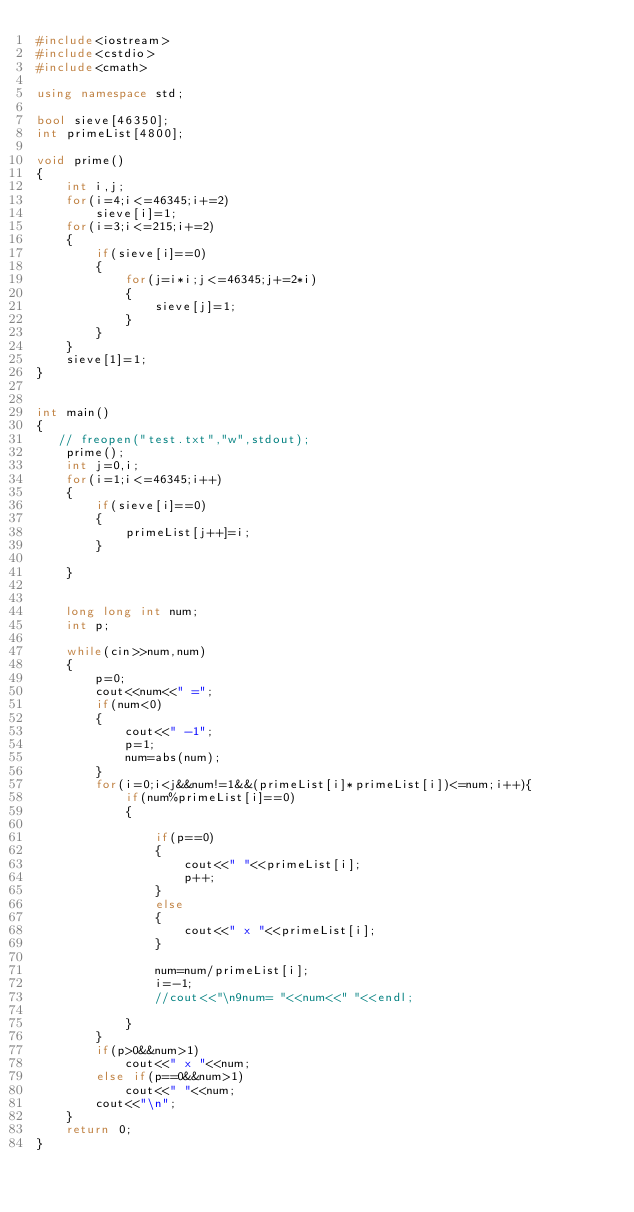Convert code to text. <code><loc_0><loc_0><loc_500><loc_500><_C++_>#include<iostream>
#include<cstdio>
#include<cmath>

using namespace std;

bool sieve[46350];
int primeList[4800];

void prime()
{
    int i,j;
    for(i=4;i<=46345;i+=2)
        sieve[i]=1;
    for(i=3;i<=215;i+=2)
    {
        if(sieve[i]==0)
        {
            for(j=i*i;j<=46345;j+=2*i)
            {
                sieve[j]=1;
            }
        }
    }
    sieve[1]=1;
}


int main()
{
   // freopen("test.txt","w",stdout);
    prime();
    int j=0,i;
    for(i=1;i<=46345;i++)
    {
        if(sieve[i]==0)
        {
            primeList[j++]=i;
        }

    }


    long long int num;
    int p;

    while(cin>>num,num)
    {
        p=0;
        cout<<num<<" =";
        if(num<0)
        {
            cout<<" -1";
            p=1;
            num=abs(num);
        }
        for(i=0;i<j&&num!=1&&(primeList[i]*primeList[i])<=num;i++){
            if(num%primeList[i]==0)
            {

                if(p==0)
                {
                    cout<<" "<<primeList[i];
                    p++;
                }
                else
                {
                    cout<<" x "<<primeList[i];
                }

                num=num/primeList[i];
                i=-1;
                //cout<<"\n9num= "<<num<<" "<<endl;

            }
        }
        if(p>0&&num>1)
            cout<<" x "<<num;
        else if(p==0&&num>1)
            cout<<" "<<num;
        cout<<"\n";
    }
    return 0;
}
</code> 